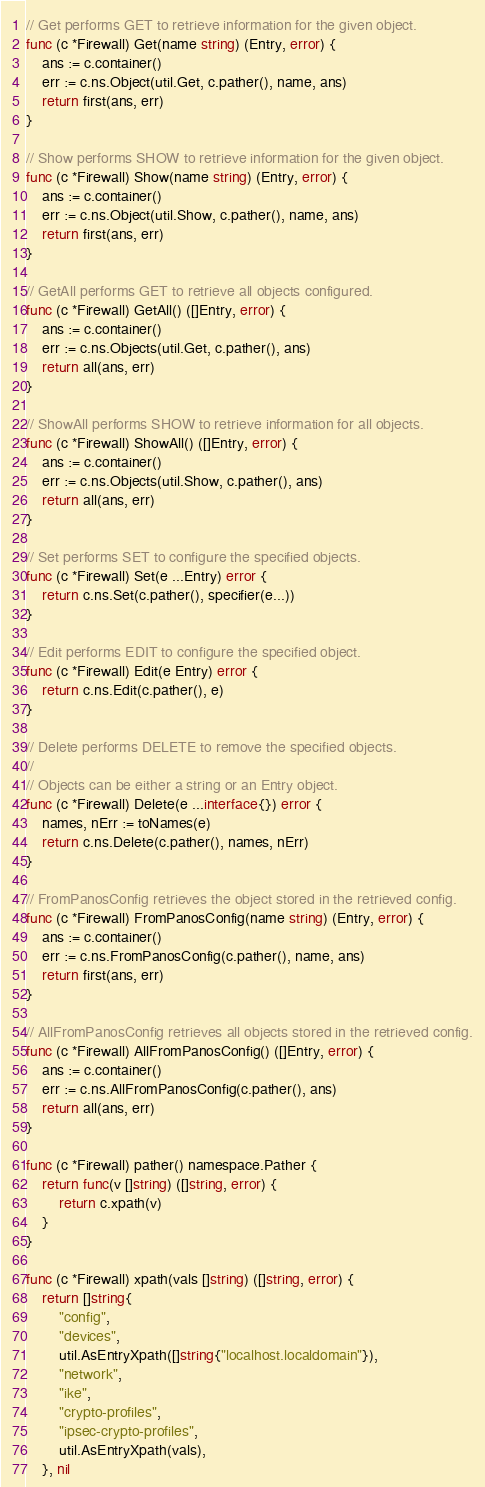Convert code to text. <code><loc_0><loc_0><loc_500><loc_500><_Go_>
// Get performs GET to retrieve information for the given object.
func (c *Firewall) Get(name string) (Entry, error) {
	ans := c.container()
	err := c.ns.Object(util.Get, c.pather(), name, ans)
	return first(ans, err)
}

// Show performs SHOW to retrieve information for the given object.
func (c *Firewall) Show(name string) (Entry, error) {
	ans := c.container()
	err := c.ns.Object(util.Show, c.pather(), name, ans)
	return first(ans, err)
}

// GetAll performs GET to retrieve all objects configured.
func (c *Firewall) GetAll() ([]Entry, error) {
	ans := c.container()
	err := c.ns.Objects(util.Get, c.pather(), ans)
	return all(ans, err)
}

// ShowAll performs SHOW to retrieve information for all objects.
func (c *Firewall) ShowAll() ([]Entry, error) {
	ans := c.container()
	err := c.ns.Objects(util.Show, c.pather(), ans)
	return all(ans, err)
}

// Set performs SET to configure the specified objects.
func (c *Firewall) Set(e ...Entry) error {
	return c.ns.Set(c.pather(), specifier(e...))
}

// Edit performs EDIT to configure the specified object.
func (c *Firewall) Edit(e Entry) error {
	return c.ns.Edit(c.pather(), e)
}

// Delete performs DELETE to remove the specified objects.
//
// Objects can be either a string or an Entry object.
func (c *Firewall) Delete(e ...interface{}) error {
	names, nErr := toNames(e)
	return c.ns.Delete(c.pather(), names, nErr)
}

// FromPanosConfig retrieves the object stored in the retrieved config.
func (c *Firewall) FromPanosConfig(name string) (Entry, error) {
	ans := c.container()
	err := c.ns.FromPanosConfig(c.pather(), name, ans)
	return first(ans, err)
}

// AllFromPanosConfig retrieves all objects stored in the retrieved config.
func (c *Firewall) AllFromPanosConfig() ([]Entry, error) {
	ans := c.container()
	err := c.ns.AllFromPanosConfig(c.pather(), ans)
	return all(ans, err)
}

func (c *Firewall) pather() namespace.Pather {
	return func(v []string) ([]string, error) {
		return c.xpath(v)
	}
}

func (c *Firewall) xpath(vals []string) ([]string, error) {
	return []string{
		"config",
		"devices",
		util.AsEntryXpath([]string{"localhost.localdomain"}),
		"network",
		"ike",
		"crypto-profiles",
		"ipsec-crypto-profiles",
		util.AsEntryXpath(vals),
	}, nil</code> 